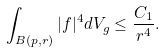Convert formula to latex. <formula><loc_0><loc_0><loc_500><loc_500>\int _ { B ( p , r ) } | f | ^ { 4 } d V _ { g } \leq \frac { C _ { 1 } } { r ^ { 4 } } .</formula> 